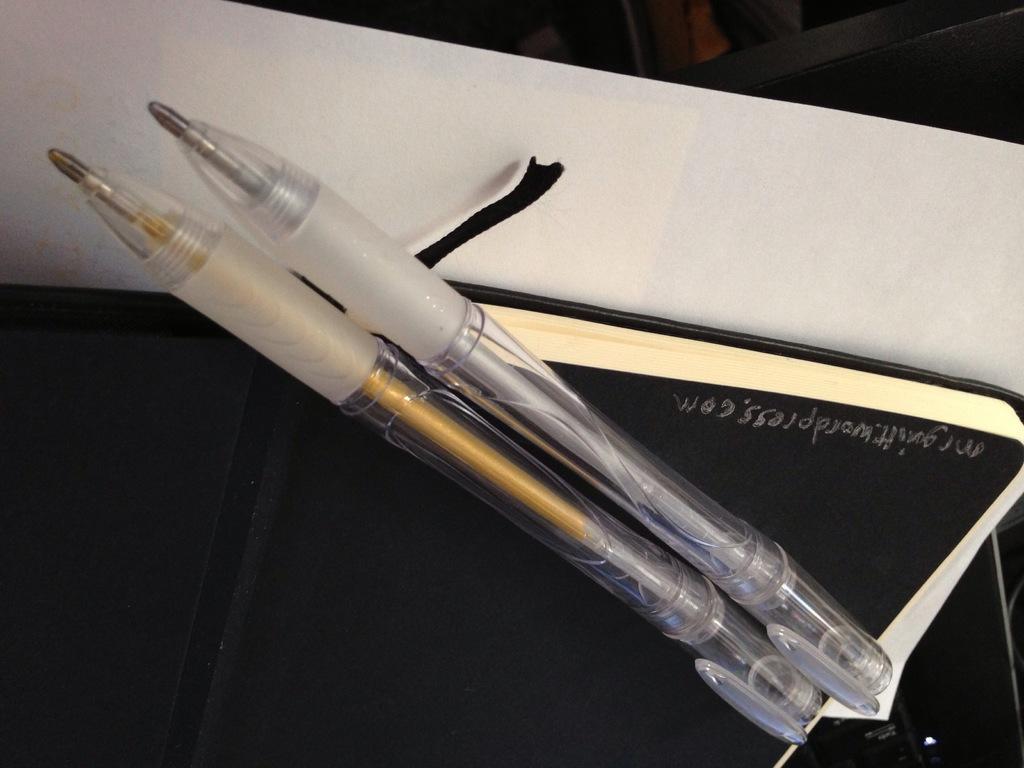Could you give a brief overview of what you see in this image? In this picture we can see two pens, book and a paper and in the background we can see some objects. 